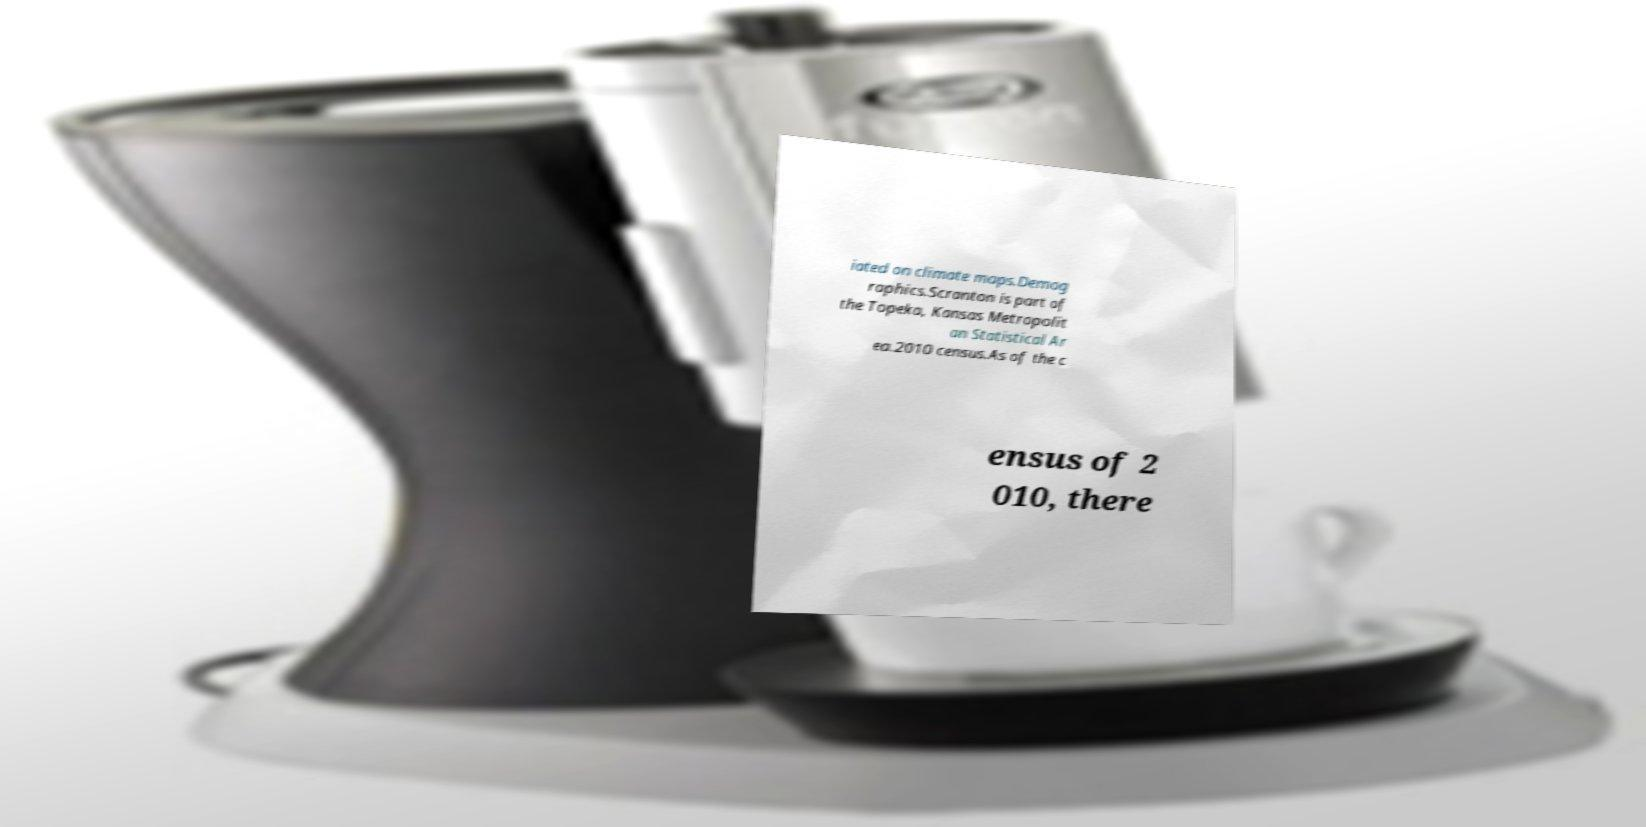Please identify and transcribe the text found in this image. iated on climate maps.Demog raphics.Scranton is part of the Topeka, Kansas Metropolit an Statistical Ar ea.2010 census.As of the c ensus of 2 010, there 